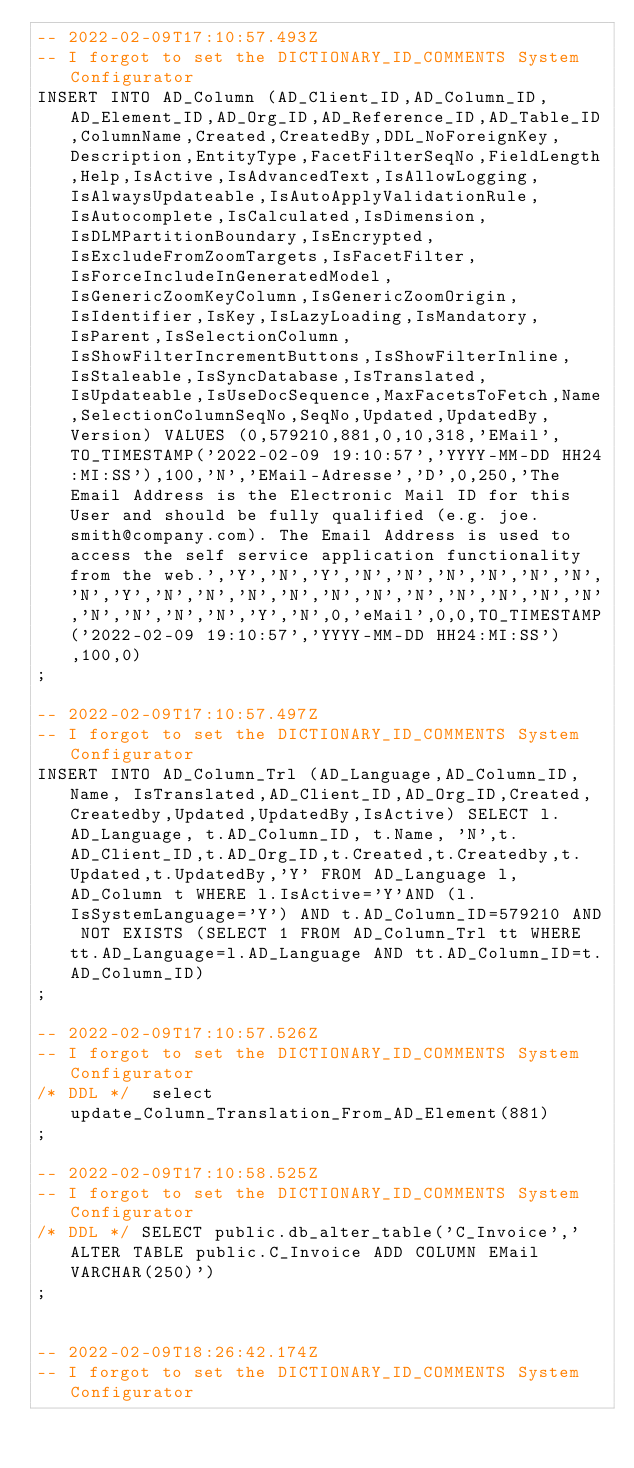<code> <loc_0><loc_0><loc_500><loc_500><_SQL_>-- 2022-02-09T17:10:57.493Z
-- I forgot to set the DICTIONARY_ID_COMMENTS System Configurator
INSERT INTO AD_Column (AD_Client_ID,AD_Column_ID,AD_Element_ID,AD_Org_ID,AD_Reference_ID,AD_Table_ID,ColumnName,Created,CreatedBy,DDL_NoForeignKey,Description,EntityType,FacetFilterSeqNo,FieldLength,Help,IsActive,IsAdvancedText,IsAllowLogging,IsAlwaysUpdateable,IsAutoApplyValidationRule,IsAutocomplete,IsCalculated,IsDimension,IsDLMPartitionBoundary,IsEncrypted,IsExcludeFromZoomTargets,IsFacetFilter,IsForceIncludeInGeneratedModel,IsGenericZoomKeyColumn,IsGenericZoomOrigin,IsIdentifier,IsKey,IsLazyLoading,IsMandatory,IsParent,IsSelectionColumn,IsShowFilterIncrementButtons,IsShowFilterInline,IsStaleable,IsSyncDatabase,IsTranslated,IsUpdateable,IsUseDocSequence,MaxFacetsToFetch,Name,SelectionColumnSeqNo,SeqNo,Updated,UpdatedBy,Version) VALUES (0,579210,881,0,10,318,'EMail',TO_TIMESTAMP('2022-02-09 19:10:57','YYYY-MM-DD HH24:MI:SS'),100,'N','EMail-Adresse','D',0,250,'The Email Address is the Electronic Mail ID for this User and should be fully qualified (e.g. joe.smith@company.com). The Email Address is used to access the self service application functionality from the web.','Y','N','Y','N','N','N','N','N','N','N','Y','N','N','N','N','N','N','N','N','N','N','N','N','N','N','N','Y','N',0,'eMail',0,0,TO_TIMESTAMP('2022-02-09 19:10:57','YYYY-MM-DD HH24:MI:SS'),100,0)
;

-- 2022-02-09T17:10:57.497Z
-- I forgot to set the DICTIONARY_ID_COMMENTS System Configurator
INSERT INTO AD_Column_Trl (AD_Language,AD_Column_ID, Name, IsTranslated,AD_Client_ID,AD_Org_ID,Created,Createdby,Updated,UpdatedBy,IsActive) SELECT l.AD_Language, t.AD_Column_ID, t.Name, 'N',t.AD_Client_ID,t.AD_Org_ID,t.Created,t.Createdby,t.Updated,t.UpdatedBy,'Y' FROM AD_Language l, AD_Column t WHERE l.IsActive='Y'AND (l.IsSystemLanguage='Y') AND t.AD_Column_ID=579210 AND NOT EXISTS (SELECT 1 FROM AD_Column_Trl tt WHERE tt.AD_Language=l.AD_Language AND tt.AD_Column_ID=t.AD_Column_ID)
;

-- 2022-02-09T17:10:57.526Z
-- I forgot to set the DICTIONARY_ID_COMMENTS System Configurator
/* DDL */  select update_Column_Translation_From_AD_Element(881) 
;

-- 2022-02-09T17:10:58.525Z
-- I forgot to set the DICTIONARY_ID_COMMENTS System Configurator
/* DDL */ SELECT public.db_alter_table('C_Invoice','ALTER TABLE public.C_Invoice ADD COLUMN EMail VARCHAR(250)')
;


-- 2022-02-09T18:26:42.174Z
-- I forgot to set the DICTIONARY_ID_COMMENTS System Configurator</code> 